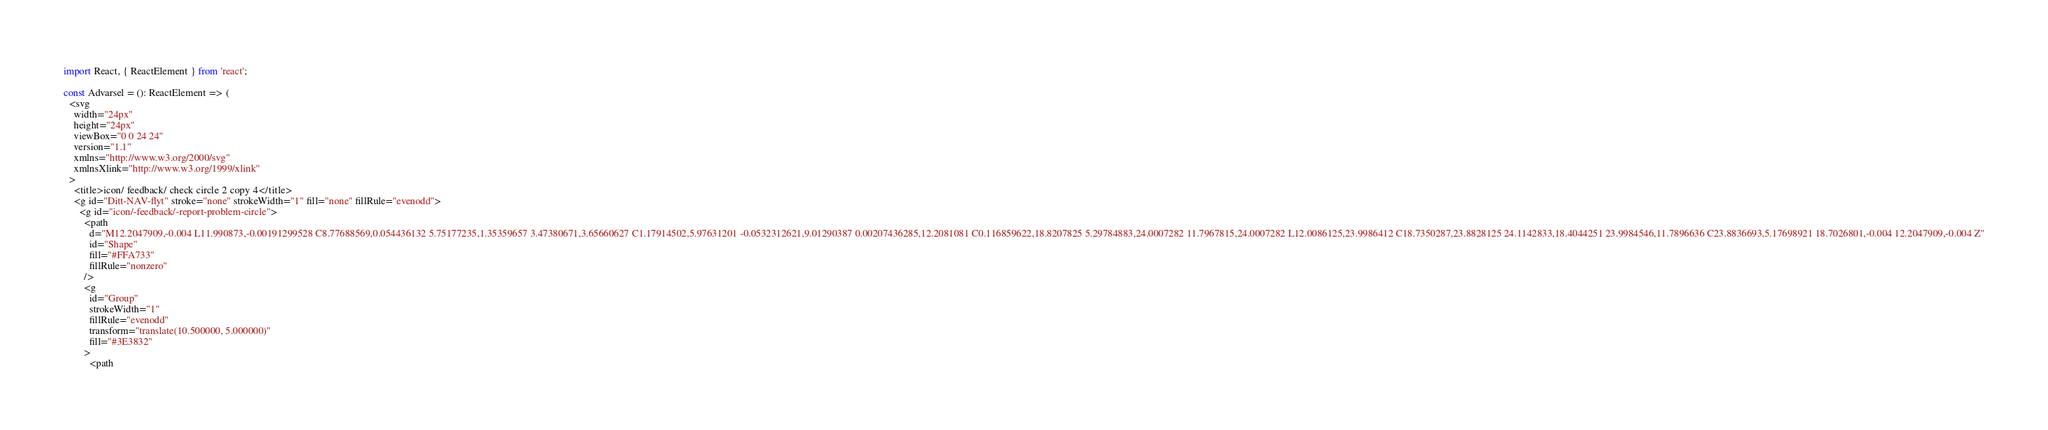Convert code to text. <code><loc_0><loc_0><loc_500><loc_500><_TypeScript_>import React, { ReactElement } from 'react';

const Advarsel = (): ReactElement => (
  <svg
    width="24px"
    height="24px"
    viewBox="0 0 24 24"
    version="1.1"
    xmlns="http://www.w3.org/2000/svg"
    xmlnsXlink="http://www.w3.org/1999/xlink"
  >
    <title>icon/ feedback/ check circle 2 copy 4</title>
    <g id="Ditt-NAV-flyt" stroke="none" strokeWidth="1" fill="none" fillRule="evenodd">
      <g id="icon/-feedback/-report-problem-circle">
        <path
          d="M12.2047909,-0.004 L11.990873,-0.00191299528 C8.77688569,0.054436132 5.75177235,1.35359657 3.47380671,3.65660627 C1.17914502,5.97631201 -0.0532312621,9.01290387 0.00207436285,12.2081081 C0.116859622,18.8207825 5.29784883,24.0007282 11.7967815,24.0007282 L12.0086125,23.9986412 C18.7350287,23.8828125 24.1142833,18.4044251 23.9984546,11.7896636 C23.8836693,5.17698921 18.7026801,-0.004 12.2047909,-0.004 Z"
          id="Shape"
          fill="#FFA733"
          fillRule="nonzero"
        />
        <g
          id="Group"
          strokeWidth="1"
          fillRule="evenodd"
          transform="translate(10.500000, 5.000000)"
          fill="#3E3832"
        >
          <path</code> 